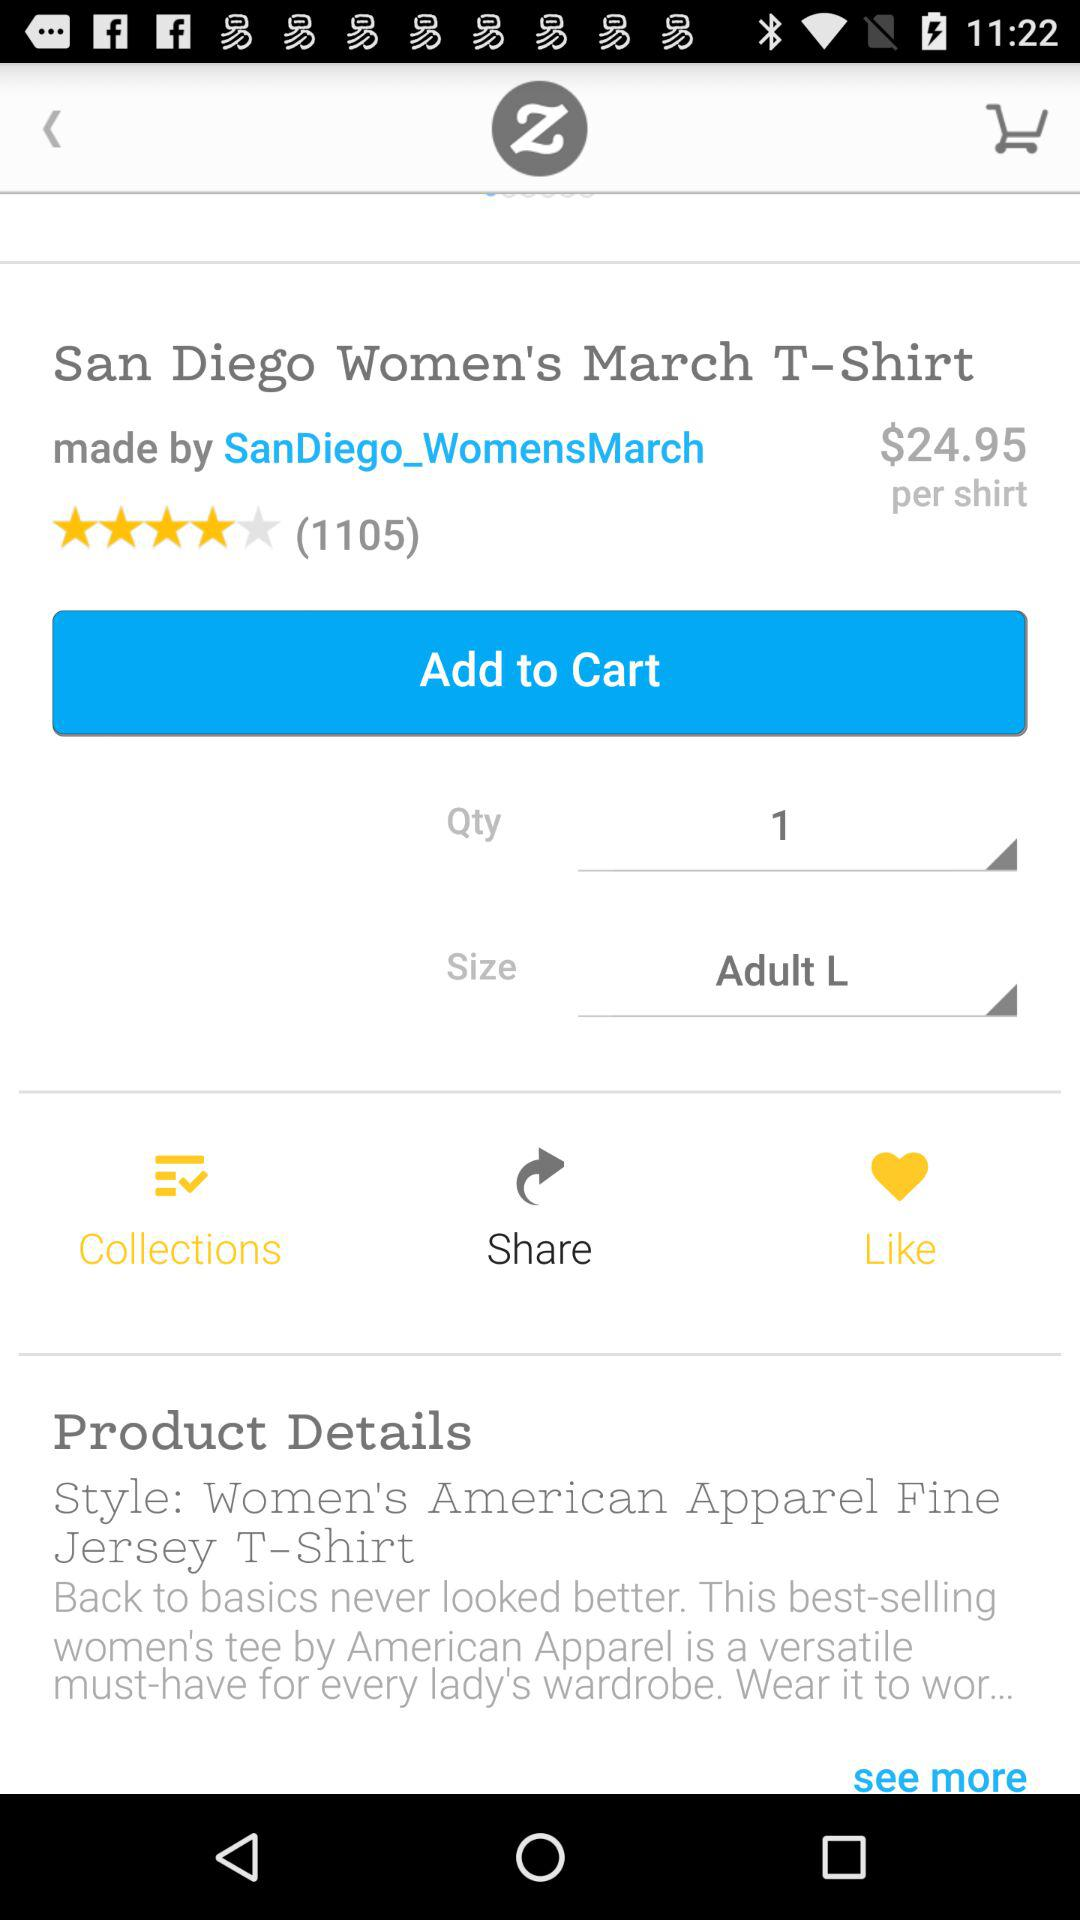How many people have rated this t-shirt? This t-shirt has been rated by 1105 people. 